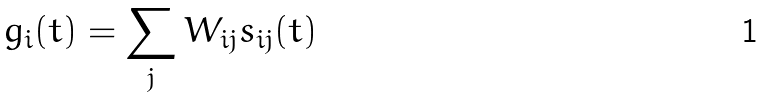Convert formula to latex. <formula><loc_0><loc_0><loc_500><loc_500>g _ { i } ( t ) = \sum _ { j } W _ { i j } s _ { i j } ( t )</formula> 